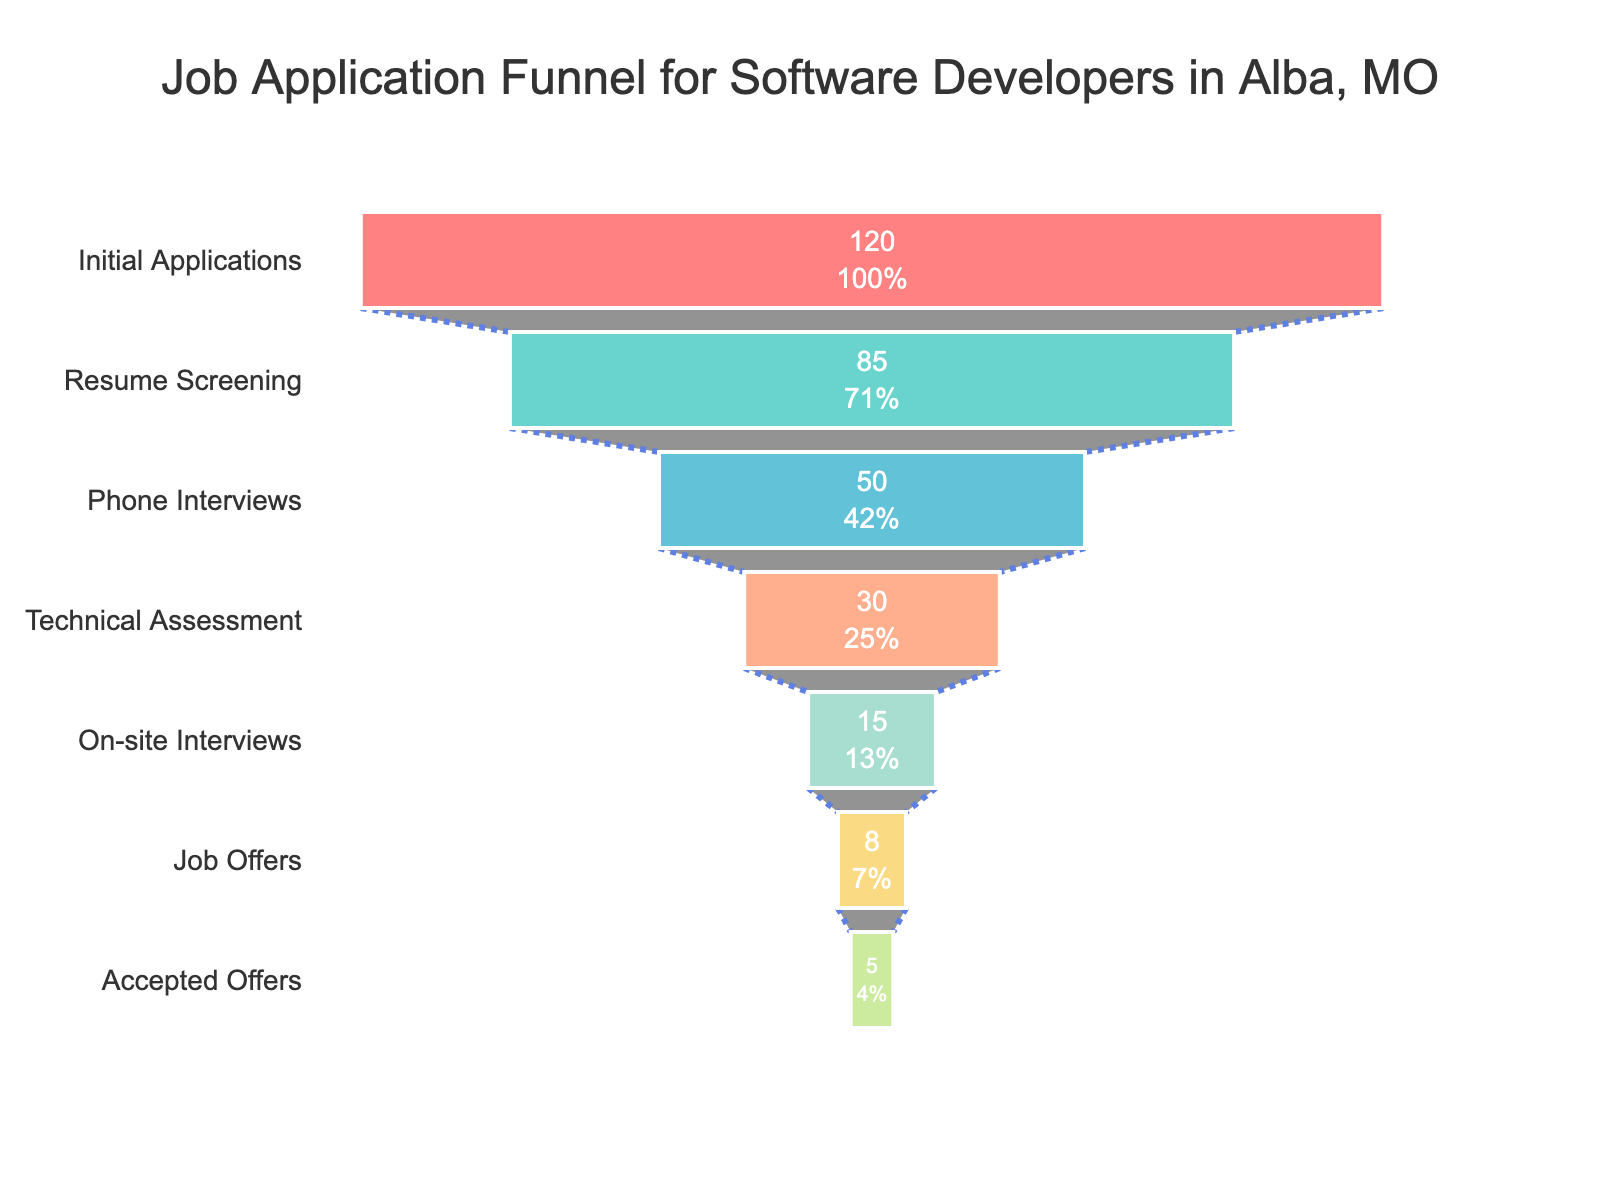What's the title of the funnel chart? The title of the chart is usually located at the top center of the figure. From the given data, the title of the funnel chart would be "Job Application Funnel for Software Developers in Alba, MO".
Answer: Job Application Funnel for Software Developers in Alba, MO How many stages are there in the job application funnel? By looking at the number of distinct stages listed along the vertical axis of the chart, we can count that there are seven stages mentioned in the data.
Answer: 7 What is the color of the segment representing "Phone Interviews"? The color of each funnel segment is specified in the variable `colors` defined in the code. According to the sequence, "Phone Interviews" is the third stage and corresponds to the third color in the list which is a shade of blue (#45B7D1).
Answer: Blue How many applicants reached the "Technical Assessment" stage? The figure lists the number of applicants for each stage. For "Technical Assessment", the visual shows that there are 30 applicants.
Answer: 30 What percentage of initial applicants received job offers? Initially, there were 120 applicants. The number of job offers made is 8. The percentage can be calculated as `(8/120) * 100 = 6.67%`.
Answer: 6.67% How many more applicants were at the "Resume Screening" stage compared to the "On-site Interviews" stage? The "Resume Screening" stage had 85 applicants while the "On-site Interviews" stage had 15. The difference is `85 - 15 = 70`.
Answer: 70 As we move from "Phone Interviews" to "Technical Assessment", what is the reduction in the number of applicants? The number of applicants decreases from 50 at "Phone Interviews" to 30 at "Technical Assessment". The reduction in numbers is `50 - 30 = 20`.
Answer: 20 Which stage had the highest drop-off in the percentage of applicants from the previous stage? The drop-off percentage is the difference between the two stages divided by the number of applicants in the previous stage, times 100. The largest percentage drop-off is from "On-site Interviews" (15) to "Job Offers" (8). The drop-off percentage is `((15 - 8) / 15) * 100 = 46.67%`.
Answer: On-site Interviews to Job Offers How many applicants accepted the job offers? The funnel chart shows the number of applicants at the "Accepted Offers" stage as 5.
Answer: 5 